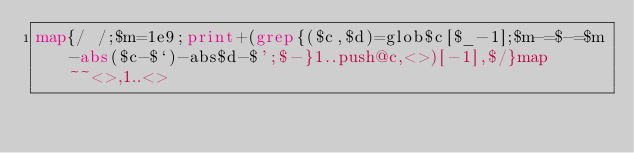Convert code to text. <code><loc_0><loc_0><loc_500><loc_500><_Perl_>map{/ /;$m=1e9;print+(grep{($c,$d)=glob$c[$_-1];$m-=$-=$m-abs($c-$`)-abs$d-$';$-}1..push@c,<>)[-1],$/}map~~<>,1..<></code> 